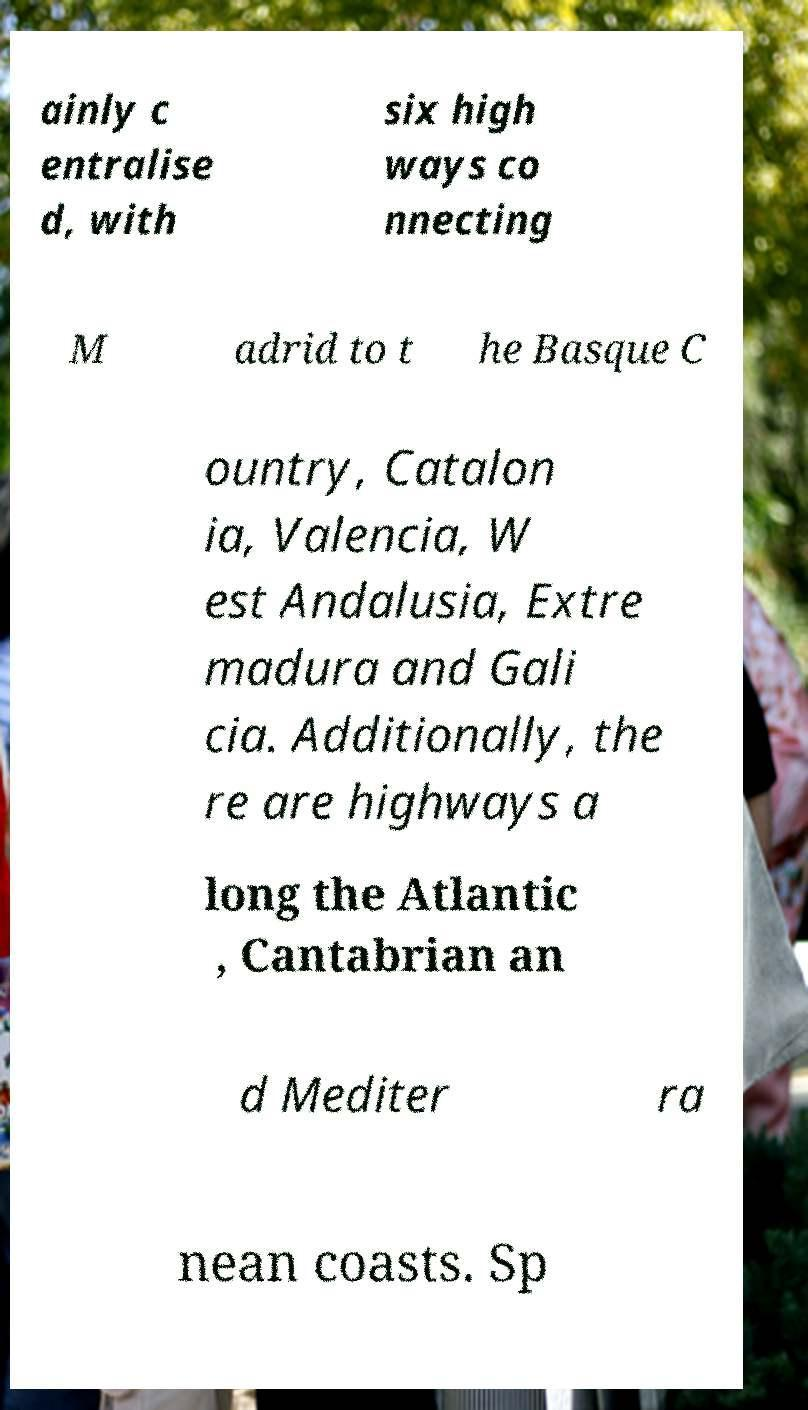Please read and relay the text visible in this image. What does it say? ainly c entralise d, with six high ways co nnecting M adrid to t he Basque C ountry, Catalon ia, Valencia, W est Andalusia, Extre madura and Gali cia. Additionally, the re are highways a long the Atlantic , Cantabrian an d Mediter ra nean coasts. Sp 